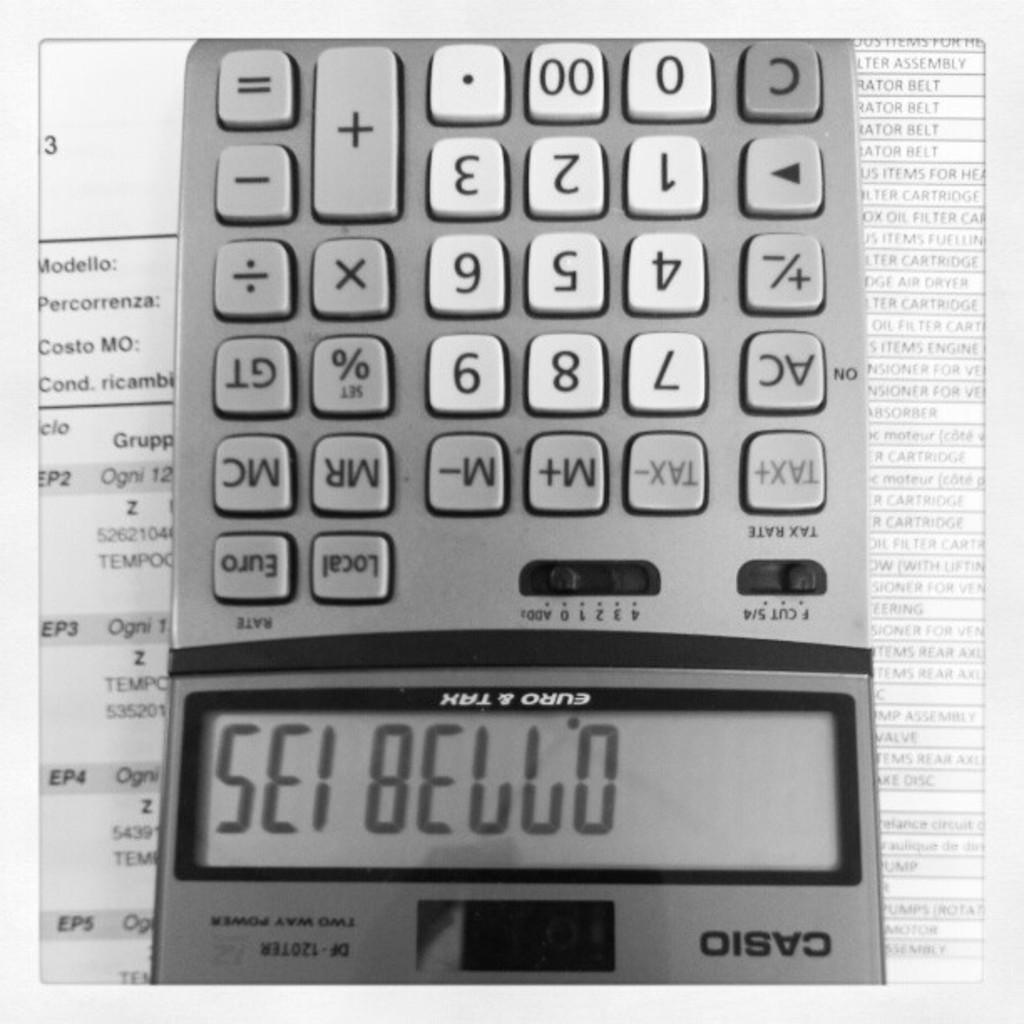What brand of calculator is this?
Ensure brevity in your answer.  Casio. 